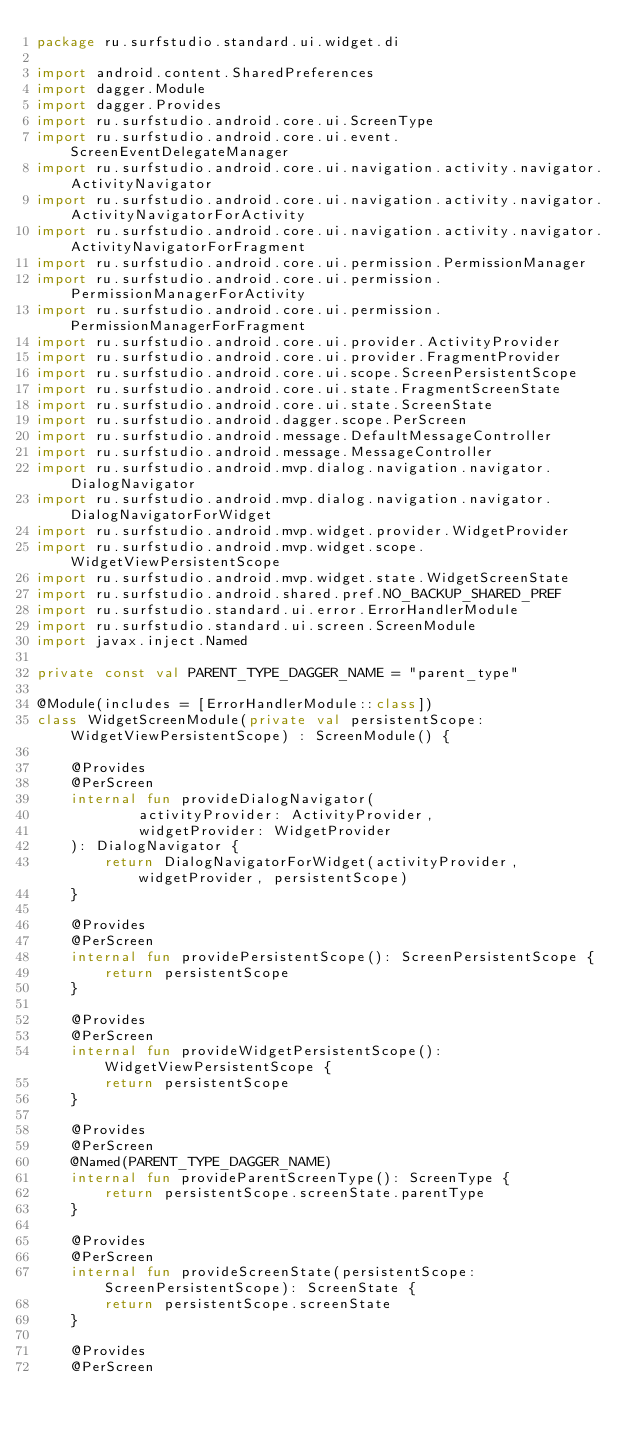<code> <loc_0><loc_0><loc_500><loc_500><_Kotlin_>package ru.surfstudio.standard.ui.widget.di

import android.content.SharedPreferences
import dagger.Module
import dagger.Provides
import ru.surfstudio.android.core.ui.ScreenType
import ru.surfstudio.android.core.ui.event.ScreenEventDelegateManager
import ru.surfstudio.android.core.ui.navigation.activity.navigator.ActivityNavigator
import ru.surfstudio.android.core.ui.navigation.activity.navigator.ActivityNavigatorForActivity
import ru.surfstudio.android.core.ui.navigation.activity.navigator.ActivityNavigatorForFragment
import ru.surfstudio.android.core.ui.permission.PermissionManager
import ru.surfstudio.android.core.ui.permission.PermissionManagerForActivity
import ru.surfstudio.android.core.ui.permission.PermissionManagerForFragment
import ru.surfstudio.android.core.ui.provider.ActivityProvider
import ru.surfstudio.android.core.ui.provider.FragmentProvider
import ru.surfstudio.android.core.ui.scope.ScreenPersistentScope
import ru.surfstudio.android.core.ui.state.FragmentScreenState
import ru.surfstudio.android.core.ui.state.ScreenState
import ru.surfstudio.android.dagger.scope.PerScreen
import ru.surfstudio.android.message.DefaultMessageController
import ru.surfstudio.android.message.MessageController
import ru.surfstudio.android.mvp.dialog.navigation.navigator.DialogNavigator
import ru.surfstudio.android.mvp.dialog.navigation.navigator.DialogNavigatorForWidget
import ru.surfstudio.android.mvp.widget.provider.WidgetProvider
import ru.surfstudio.android.mvp.widget.scope.WidgetViewPersistentScope
import ru.surfstudio.android.mvp.widget.state.WidgetScreenState
import ru.surfstudio.android.shared.pref.NO_BACKUP_SHARED_PREF
import ru.surfstudio.standard.ui.error.ErrorHandlerModule
import ru.surfstudio.standard.ui.screen.ScreenModule
import javax.inject.Named

private const val PARENT_TYPE_DAGGER_NAME = "parent_type"

@Module(includes = [ErrorHandlerModule::class])
class WidgetScreenModule(private val persistentScope: WidgetViewPersistentScope) : ScreenModule() {

    @Provides
    @PerScreen
    internal fun provideDialogNavigator(
            activityProvider: ActivityProvider,
            widgetProvider: WidgetProvider
    ): DialogNavigator {
        return DialogNavigatorForWidget(activityProvider, widgetProvider, persistentScope)
    }

    @Provides
    @PerScreen
    internal fun providePersistentScope(): ScreenPersistentScope {
        return persistentScope
    }

    @Provides
    @PerScreen
    internal fun provideWidgetPersistentScope(): WidgetViewPersistentScope {
        return persistentScope
    }

    @Provides
    @PerScreen
    @Named(PARENT_TYPE_DAGGER_NAME)
    internal fun provideParentScreenType(): ScreenType {
        return persistentScope.screenState.parentType
    }

    @Provides
    @PerScreen
    internal fun provideScreenState(persistentScope: ScreenPersistentScope): ScreenState {
        return persistentScope.screenState
    }

    @Provides
    @PerScreen</code> 